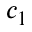Convert formula to latex. <formula><loc_0><loc_0><loc_500><loc_500>c _ { 1 }</formula> 